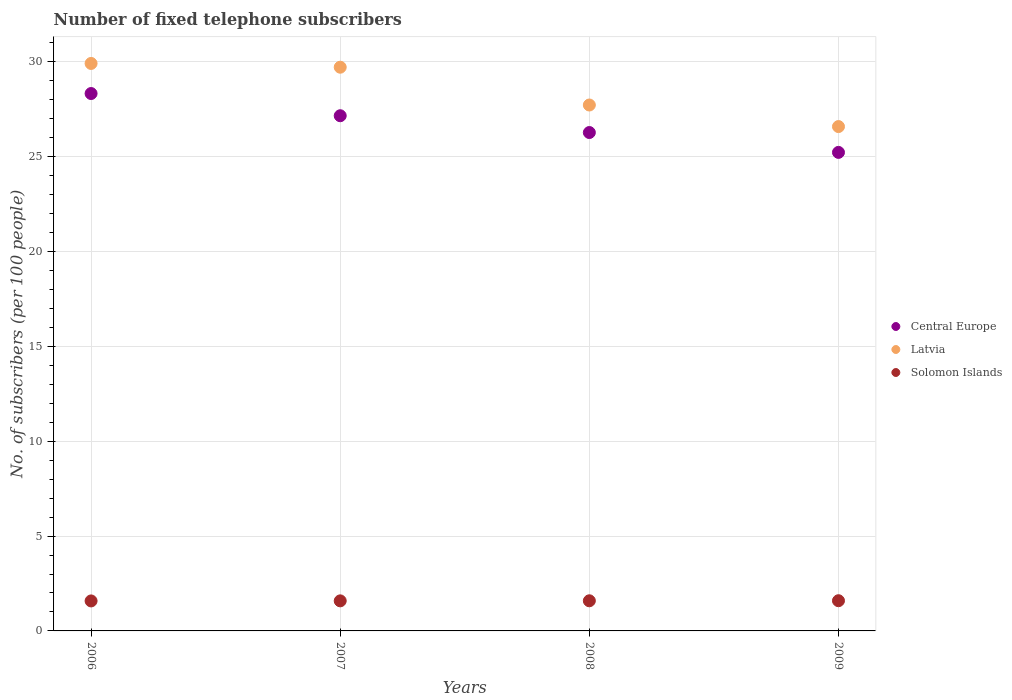How many different coloured dotlines are there?
Your answer should be very brief. 3. What is the number of fixed telephone subscribers in Solomon Islands in 2006?
Your answer should be compact. 1.58. Across all years, what is the maximum number of fixed telephone subscribers in Central Europe?
Your response must be concise. 28.33. Across all years, what is the minimum number of fixed telephone subscribers in Latvia?
Give a very brief answer. 26.59. In which year was the number of fixed telephone subscribers in Central Europe minimum?
Ensure brevity in your answer.  2009. What is the total number of fixed telephone subscribers in Solomon Islands in the graph?
Keep it short and to the point. 6.35. What is the difference between the number of fixed telephone subscribers in Latvia in 2008 and that in 2009?
Offer a terse response. 1.14. What is the difference between the number of fixed telephone subscribers in Latvia in 2008 and the number of fixed telephone subscribers in Central Europe in 2007?
Your answer should be very brief. 0.57. What is the average number of fixed telephone subscribers in Solomon Islands per year?
Your answer should be compact. 1.59. In the year 2006, what is the difference between the number of fixed telephone subscribers in Central Europe and number of fixed telephone subscribers in Latvia?
Your answer should be very brief. -1.59. What is the ratio of the number of fixed telephone subscribers in Central Europe in 2006 to that in 2007?
Keep it short and to the point. 1.04. Is the difference between the number of fixed telephone subscribers in Central Europe in 2006 and 2008 greater than the difference between the number of fixed telephone subscribers in Latvia in 2006 and 2008?
Ensure brevity in your answer.  No. What is the difference between the highest and the second highest number of fixed telephone subscribers in Solomon Islands?
Keep it short and to the point. 0. What is the difference between the highest and the lowest number of fixed telephone subscribers in Latvia?
Give a very brief answer. 3.33. Is the number of fixed telephone subscribers in Central Europe strictly less than the number of fixed telephone subscribers in Solomon Islands over the years?
Provide a short and direct response. No. How many years are there in the graph?
Your answer should be compact. 4. Does the graph contain grids?
Provide a succinct answer. Yes. Where does the legend appear in the graph?
Your answer should be very brief. Center right. How many legend labels are there?
Provide a short and direct response. 3. What is the title of the graph?
Your answer should be very brief. Number of fixed telephone subscribers. What is the label or title of the Y-axis?
Offer a terse response. No. of subscribers (per 100 people). What is the No. of subscribers (per 100 people) in Central Europe in 2006?
Your response must be concise. 28.33. What is the No. of subscribers (per 100 people) of Latvia in 2006?
Your answer should be compact. 29.92. What is the No. of subscribers (per 100 people) in Solomon Islands in 2006?
Make the answer very short. 1.58. What is the No. of subscribers (per 100 people) in Central Europe in 2007?
Ensure brevity in your answer.  27.16. What is the No. of subscribers (per 100 people) of Latvia in 2007?
Offer a terse response. 29.72. What is the No. of subscribers (per 100 people) in Solomon Islands in 2007?
Your response must be concise. 1.58. What is the No. of subscribers (per 100 people) of Central Europe in 2008?
Provide a succinct answer. 26.27. What is the No. of subscribers (per 100 people) of Latvia in 2008?
Your answer should be very brief. 27.73. What is the No. of subscribers (per 100 people) in Solomon Islands in 2008?
Ensure brevity in your answer.  1.59. What is the No. of subscribers (per 100 people) in Central Europe in 2009?
Ensure brevity in your answer.  25.23. What is the No. of subscribers (per 100 people) in Latvia in 2009?
Your answer should be compact. 26.59. What is the No. of subscribers (per 100 people) of Solomon Islands in 2009?
Keep it short and to the point. 1.59. Across all years, what is the maximum No. of subscribers (per 100 people) of Central Europe?
Keep it short and to the point. 28.33. Across all years, what is the maximum No. of subscribers (per 100 people) of Latvia?
Ensure brevity in your answer.  29.92. Across all years, what is the maximum No. of subscribers (per 100 people) of Solomon Islands?
Offer a very short reply. 1.59. Across all years, what is the minimum No. of subscribers (per 100 people) in Central Europe?
Ensure brevity in your answer.  25.23. Across all years, what is the minimum No. of subscribers (per 100 people) of Latvia?
Make the answer very short. 26.59. Across all years, what is the minimum No. of subscribers (per 100 people) in Solomon Islands?
Give a very brief answer. 1.58. What is the total No. of subscribers (per 100 people) of Central Europe in the graph?
Offer a very short reply. 106.99. What is the total No. of subscribers (per 100 people) in Latvia in the graph?
Offer a terse response. 113.95. What is the total No. of subscribers (per 100 people) of Solomon Islands in the graph?
Keep it short and to the point. 6.35. What is the difference between the No. of subscribers (per 100 people) in Central Europe in 2006 and that in 2007?
Provide a succinct answer. 1.17. What is the difference between the No. of subscribers (per 100 people) of Latvia in 2006 and that in 2007?
Offer a terse response. 0.2. What is the difference between the No. of subscribers (per 100 people) of Solomon Islands in 2006 and that in 2007?
Provide a short and direct response. -0. What is the difference between the No. of subscribers (per 100 people) of Central Europe in 2006 and that in 2008?
Provide a short and direct response. 2.06. What is the difference between the No. of subscribers (per 100 people) in Latvia in 2006 and that in 2008?
Offer a terse response. 2.19. What is the difference between the No. of subscribers (per 100 people) in Solomon Islands in 2006 and that in 2008?
Your answer should be very brief. -0.01. What is the difference between the No. of subscribers (per 100 people) in Central Europe in 2006 and that in 2009?
Your answer should be very brief. 3.1. What is the difference between the No. of subscribers (per 100 people) in Latvia in 2006 and that in 2009?
Offer a terse response. 3.33. What is the difference between the No. of subscribers (per 100 people) in Solomon Islands in 2006 and that in 2009?
Your response must be concise. -0.01. What is the difference between the No. of subscribers (per 100 people) of Central Europe in 2007 and that in 2008?
Ensure brevity in your answer.  0.89. What is the difference between the No. of subscribers (per 100 people) in Latvia in 2007 and that in 2008?
Offer a terse response. 1.99. What is the difference between the No. of subscribers (per 100 people) of Solomon Islands in 2007 and that in 2008?
Make the answer very short. -0. What is the difference between the No. of subscribers (per 100 people) in Central Europe in 2007 and that in 2009?
Offer a terse response. 1.93. What is the difference between the No. of subscribers (per 100 people) of Latvia in 2007 and that in 2009?
Provide a short and direct response. 3.13. What is the difference between the No. of subscribers (per 100 people) of Solomon Islands in 2007 and that in 2009?
Your answer should be compact. -0.01. What is the difference between the No. of subscribers (per 100 people) in Central Europe in 2008 and that in 2009?
Offer a very short reply. 1.05. What is the difference between the No. of subscribers (per 100 people) in Latvia in 2008 and that in 2009?
Make the answer very short. 1.14. What is the difference between the No. of subscribers (per 100 people) of Solomon Islands in 2008 and that in 2009?
Provide a short and direct response. -0. What is the difference between the No. of subscribers (per 100 people) in Central Europe in 2006 and the No. of subscribers (per 100 people) in Latvia in 2007?
Make the answer very short. -1.39. What is the difference between the No. of subscribers (per 100 people) of Central Europe in 2006 and the No. of subscribers (per 100 people) of Solomon Islands in 2007?
Offer a very short reply. 26.75. What is the difference between the No. of subscribers (per 100 people) in Latvia in 2006 and the No. of subscribers (per 100 people) in Solomon Islands in 2007?
Your answer should be compact. 28.33. What is the difference between the No. of subscribers (per 100 people) in Central Europe in 2006 and the No. of subscribers (per 100 people) in Latvia in 2008?
Keep it short and to the point. 0.6. What is the difference between the No. of subscribers (per 100 people) in Central Europe in 2006 and the No. of subscribers (per 100 people) in Solomon Islands in 2008?
Make the answer very short. 26.74. What is the difference between the No. of subscribers (per 100 people) in Latvia in 2006 and the No. of subscribers (per 100 people) in Solomon Islands in 2008?
Keep it short and to the point. 28.33. What is the difference between the No. of subscribers (per 100 people) in Central Europe in 2006 and the No. of subscribers (per 100 people) in Latvia in 2009?
Keep it short and to the point. 1.74. What is the difference between the No. of subscribers (per 100 people) of Central Europe in 2006 and the No. of subscribers (per 100 people) of Solomon Islands in 2009?
Offer a terse response. 26.74. What is the difference between the No. of subscribers (per 100 people) in Latvia in 2006 and the No. of subscribers (per 100 people) in Solomon Islands in 2009?
Provide a succinct answer. 28.32. What is the difference between the No. of subscribers (per 100 people) in Central Europe in 2007 and the No. of subscribers (per 100 people) in Latvia in 2008?
Ensure brevity in your answer.  -0.57. What is the difference between the No. of subscribers (per 100 people) of Central Europe in 2007 and the No. of subscribers (per 100 people) of Solomon Islands in 2008?
Offer a terse response. 25.57. What is the difference between the No. of subscribers (per 100 people) in Latvia in 2007 and the No. of subscribers (per 100 people) in Solomon Islands in 2008?
Offer a very short reply. 28.13. What is the difference between the No. of subscribers (per 100 people) of Central Europe in 2007 and the No. of subscribers (per 100 people) of Latvia in 2009?
Keep it short and to the point. 0.57. What is the difference between the No. of subscribers (per 100 people) of Central Europe in 2007 and the No. of subscribers (per 100 people) of Solomon Islands in 2009?
Make the answer very short. 25.57. What is the difference between the No. of subscribers (per 100 people) of Latvia in 2007 and the No. of subscribers (per 100 people) of Solomon Islands in 2009?
Provide a succinct answer. 28.13. What is the difference between the No. of subscribers (per 100 people) of Central Europe in 2008 and the No. of subscribers (per 100 people) of Latvia in 2009?
Make the answer very short. -0.31. What is the difference between the No. of subscribers (per 100 people) of Central Europe in 2008 and the No. of subscribers (per 100 people) of Solomon Islands in 2009?
Your answer should be compact. 24.68. What is the difference between the No. of subscribers (per 100 people) of Latvia in 2008 and the No. of subscribers (per 100 people) of Solomon Islands in 2009?
Offer a terse response. 26.13. What is the average No. of subscribers (per 100 people) of Central Europe per year?
Your answer should be compact. 26.75. What is the average No. of subscribers (per 100 people) of Latvia per year?
Provide a succinct answer. 28.49. What is the average No. of subscribers (per 100 people) of Solomon Islands per year?
Offer a terse response. 1.59. In the year 2006, what is the difference between the No. of subscribers (per 100 people) of Central Europe and No. of subscribers (per 100 people) of Latvia?
Ensure brevity in your answer.  -1.59. In the year 2006, what is the difference between the No. of subscribers (per 100 people) in Central Europe and No. of subscribers (per 100 people) in Solomon Islands?
Give a very brief answer. 26.75. In the year 2006, what is the difference between the No. of subscribers (per 100 people) in Latvia and No. of subscribers (per 100 people) in Solomon Islands?
Your answer should be very brief. 28.34. In the year 2007, what is the difference between the No. of subscribers (per 100 people) of Central Europe and No. of subscribers (per 100 people) of Latvia?
Give a very brief answer. -2.56. In the year 2007, what is the difference between the No. of subscribers (per 100 people) in Central Europe and No. of subscribers (per 100 people) in Solomon Islands?
Give a very brief answer. 25.58. In the year 2007, what is the difference between the No. of subscribers (per 100 people) in Latvia and No. of subscribers (per 100 people) in Solomon Islands?
Provide a succinct answer. 28.13. In the year 2008, what is the difference between the No. of subscribers (per 100 people) of Central Europe and No. of subscribers (per 100 people) of Latvia?
Offer a terse response. -1.45. In the year 2008, what is the difference between the No. of subscribers (per 100 people) in Central Europe and No. of subscribers (per 100 people) in Solomon Islands?
Your answer should be very brief. 24.69. In the year 2008, what is the difference between the No. of subscribers (per 100 people) in Latvia and No. of subscribers (per 100 people) in Solomon Islands?
Ensure brevity in your answer.  26.14. In the year 2009, what is the difference between the No. of subscribers (per 100 people) of Central Europe and No. of subscribers (per 100 people) of Latvia?
Give a very brief answer. -1.36. In the year 2009, what is the difference between the No. of subscribers (per 100 people) in Central Europe and No. of subscribers (per 100 people) in Solomon Islands?
Your answer should be very brief. 23.64. In the year 2009, what is the difference between the No. of subscribers (per 100 people) in Latvia and No. of subscribers (per 100 people) in Solomon Islands?
Make the answer very short. 25. What is the ratio of the No. of subscribers (per 100 people) of Central Europe in 2006 to that in 2007?
Provide a short and direct response. 1.04. What is the ratio of the No. of subscribers (per 100 people) in Latvia in 2006 to that in 2007?
Give a very brief answer. 1.01. What is the ratio of the No. of subscribers (per 100 people) of Solomon Islands in 2006 to that in 2007?
Offer a very short reply. 1. What is the ratio of the No. of subscribers (per 100 people) in Central Europe in 2006 to that in 2008?
Make the answer very short. 1.08. What is the ratio of the No. of subscribers (per 100 people) in Latvia in 2006 to that in 2008?
Your answer should be very brief. 1.08. What is the ratio of the No. of subscribers (per 100 people) of Central Europe in 2006 to that in 2009?
Your answer should be very brief. 1.12. What is the ratio of the No. of subscribers (per 100 people) of Latvia in 2006 to that in 2009?
Your answer should be very brief. 1.13. What is the ratio of the No. of subscribers (per 100 people) in Solomon Islands in 2006 to that in 2009?
Provide a succinct answer. 0.99. What is the ratio of the No. of subscribers (per 100 people) in Central Europe in 2007 to that in 2008?
Provide a short and direct response. 1.03. What is the ratio of the No. of subscribers (per 100 people) of Latvia in 2007 to that in 2008?
Your response must be concise. 1.07. What is the ratio of the No. of subscribers (per 100 people) in Central Europe in 2007 to that in 2009?
Ensure brevity in your answer.  1.08. What is the ratio of the No. of subscribers (per 100 people) of Latvia in 2007 to that in 2009?
Offer a very short reply. 1.12. What is the ratio of the No. of subscribers (per 100 people) in Solomon Islands in 2007 to that in 2009?
Provide a succinct answer. 1. What is the ratio of the No. of subscribers (per 100 people) in Central Europe in 2008 to that in 2009?
Your answer should be very brief. 1.04. What is the ratio of the No. of subscribers (per 100 people) of Latvia in 2008 to that in 2009?
Provide a short and direct response. 1.04. What is the difference between the highest and the second highest No. of subscribers (per 100 people) in Central Europe?
Your answer should be very brief. 1.17. What is the difference between the highest and the second highest No. of subscribers (per 100 people) of Latvia?
Make the answer very short. 0.2. What is the difference between the highest and the second highest No. of subscribers (per 100 people) of Solomon Islands?
Provide a short and direct response. 0. What is the difference between the highest and the lowest No. of subscribers (per 100 people) of Central Europe?
Make the answer very short. 3.1. What is the difference between the highest and the lowest No. of subscribers (per 100 people) of Latvia?
Keep it short and to the point. 3.33. What is the difference between the highest and the lowest No. of subscribers (per 100 people) of Solomon Islands?
Make the answer very short. 0.01. 